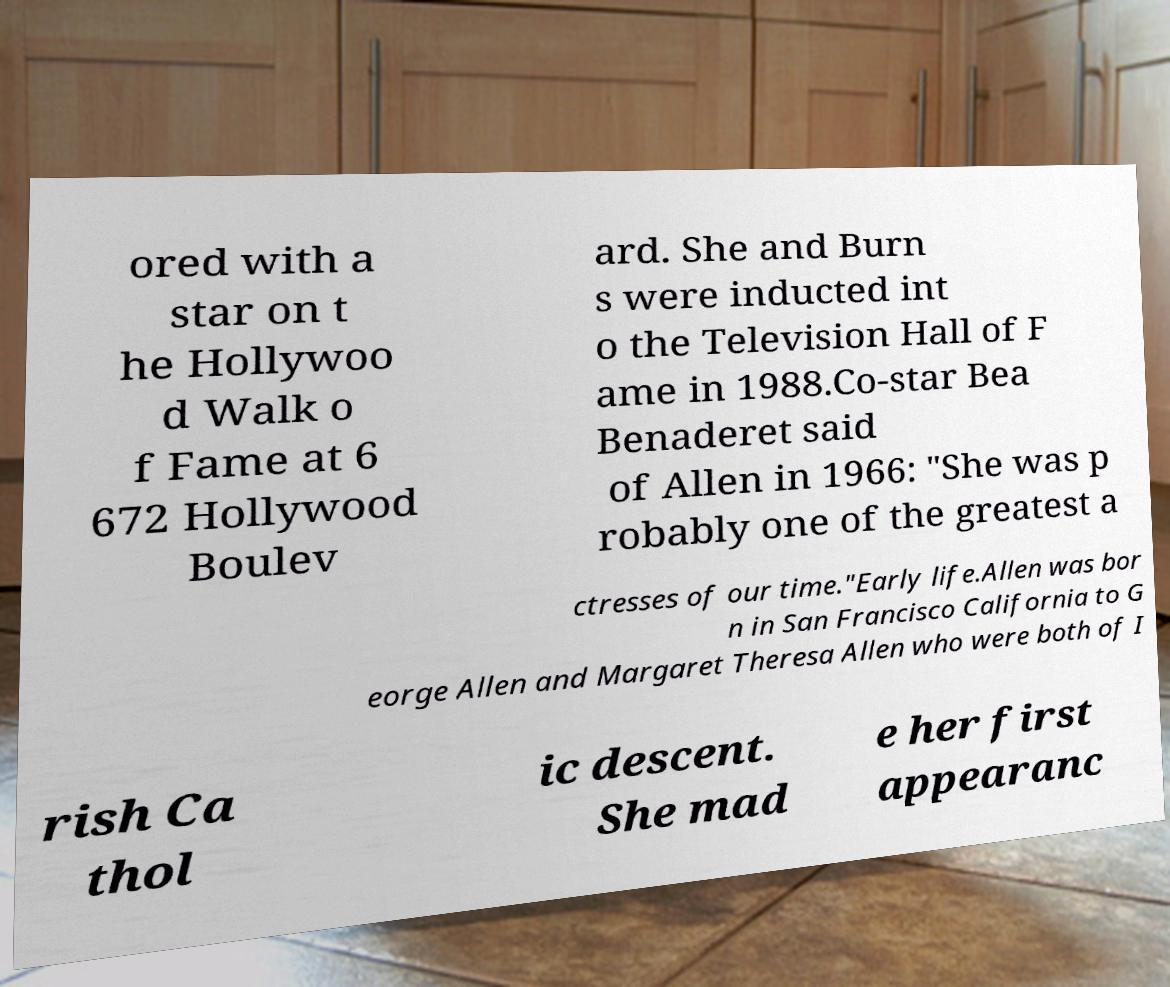Please read and relay the text visible in this image. What does it say? ored with a star on t he Hollywoo d Walk o f Fame at 6 672 Hollywood Boulev ard. She and Burn s were inducted int o the Television Hall of F ame in 1988.Co-star Bea Benaderet said of Allen in 1966: "She was p robably one of the greatest a ctresses of our time."Early life.Allen was bor n in San Francisco California to G eorge Allen and Margaret Theresa Allen who were both of I rish Ca thol ic descent. She mad e her first appearanc 